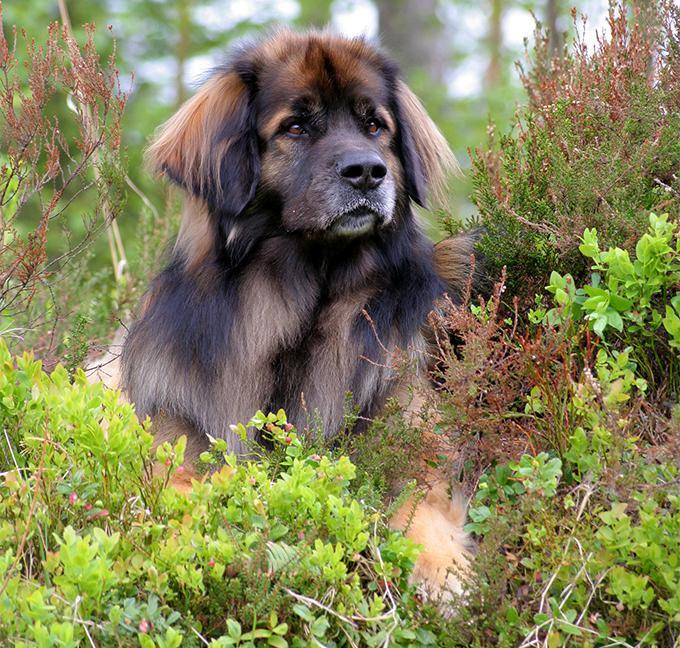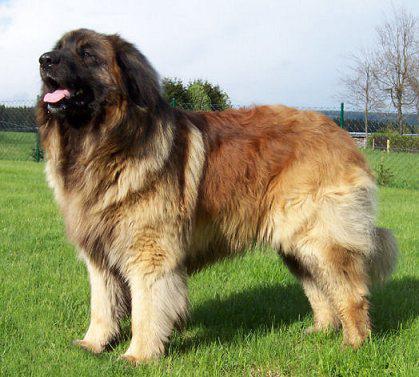The first image is the image on the left, the second image is the image on the right. For the images shown, is this caption "One dog is sitting in the short grass in the image on the left." true? Answer yes or no. No. The first image is the image on the left, the second image is the image on the right. For the images displayed, is the sentence "Right image contains more dogs than the left image." factually correct? Answer yes or no. No. 